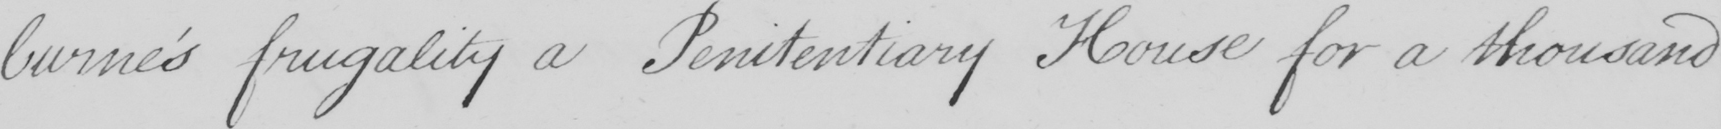Can you read and transcribe this handwriting? -burne ' s frugality a Penitentiary House for a thousand 